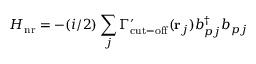Convert formula to latex. <formula><loc_0><loc_0><loc_500><loc_500>H _ { n r } = - ( i / 2 ) \sum _ { j } \Gamma _ { c u t - o f f } ^ { \prime } ( { r } _ { j } ) b _ { p j } ^ { \dagger } b _ { p j }</formula> 